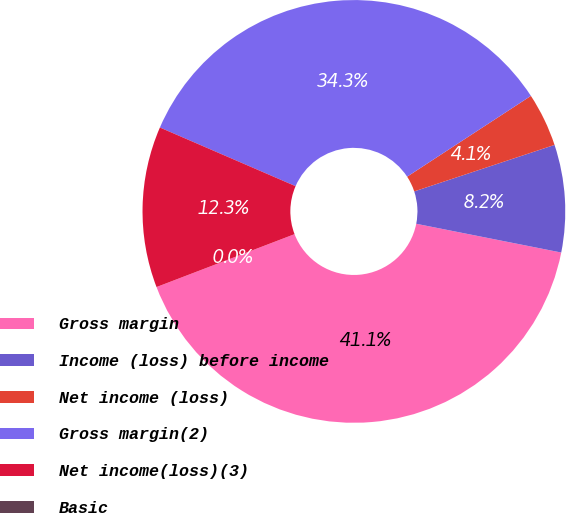<chart> <loc_0><loc_0><loc_500><loc_500><pie_chart><fcel>Gross margin<fcel>Income (loss) before income<fcel>Net income (loss)<fcel>Gross margin(2)<fcel>Net income(loss)(3)<fcel>Basic<nl><fcel>41.06%<fcel>8.21%<fcel>4.11%<fcel>34.3%<fcel>12.32%<fcel>0.0%<nl></chart> 